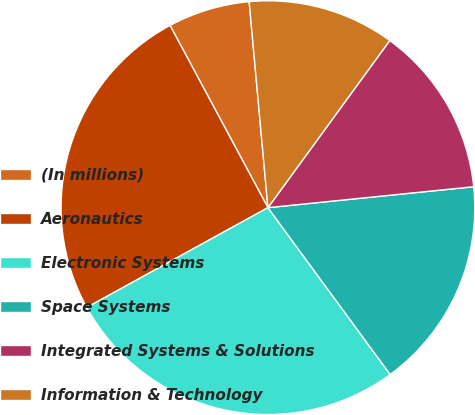<chart> <loc_0><loc_0><loc_500><loc_500><pie_chart><fcel>(In millions)<fcel>Aeronautics<fcel>Electronic Systems<fcel>Space Systems<fcel>Integrated Systems & Solutions<fcel>Information & Technology<nl><fcel>6.4%<fcel>25.17%<fcel>27.05%<fcel>16.55%<fcel>13.36%<fcel>11.47%<nl></chart> 